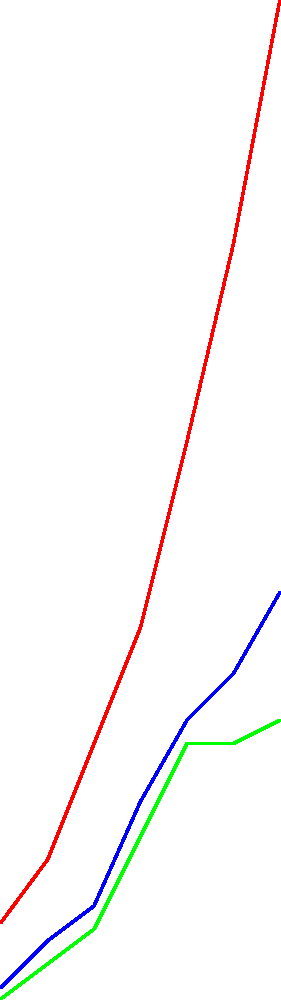As an Iowa genealogist, you're analyzing population trends in three major counties. Based on the line graph showing population growth from 1900 to 2020, which county experienced the most significant population increase between 1960 and 2020, and what factors might have contributed to this growth? To answer this question, we need to analyze the population growth trends for each county from 1960 to 2020:

1. Identify the population values for each county in 1960 and 2020:
   Polk County: 1960 (210,000), 2020 (480,000)
   Linn County: 1960 (135,000), 2020 (225,000)
   Scott County: 1960 (120,000), 2020 (170,000)

2. Calculate the population increase for each county:
   Polk County: 480,000 - 210,000 = 270,000
   Linn County: 225,000 - 135,000 = 90,000
   Scott County: 170,000 - 120,000 = 50,000

3. Compare the increases:
   Polk County had the largest increase of 270,000 people.

4. Factors that might have contributed to Polk County's growth:
   a. Des Moines, the state capital, is located in Polk County, attracting government jobs and related industries.
   b. Economic diversification, including growth in insurance, finance, and technology sectors.
   c. Urban expansion and suburban development around Des Moines.
   d. Educational institutions, such as Drake University, attracting students and faculty.
   e. Improved infrastructure and transportation networks.
   f. Cultural amenities and quality of life factors drawing new residents.

As a genealogist, this population growth would indicate a significant increase in family histories and records to research in Polk County during this period.
Answer: Polk County; factors include being home to the state capital, economic diversification, and urban expansion. 